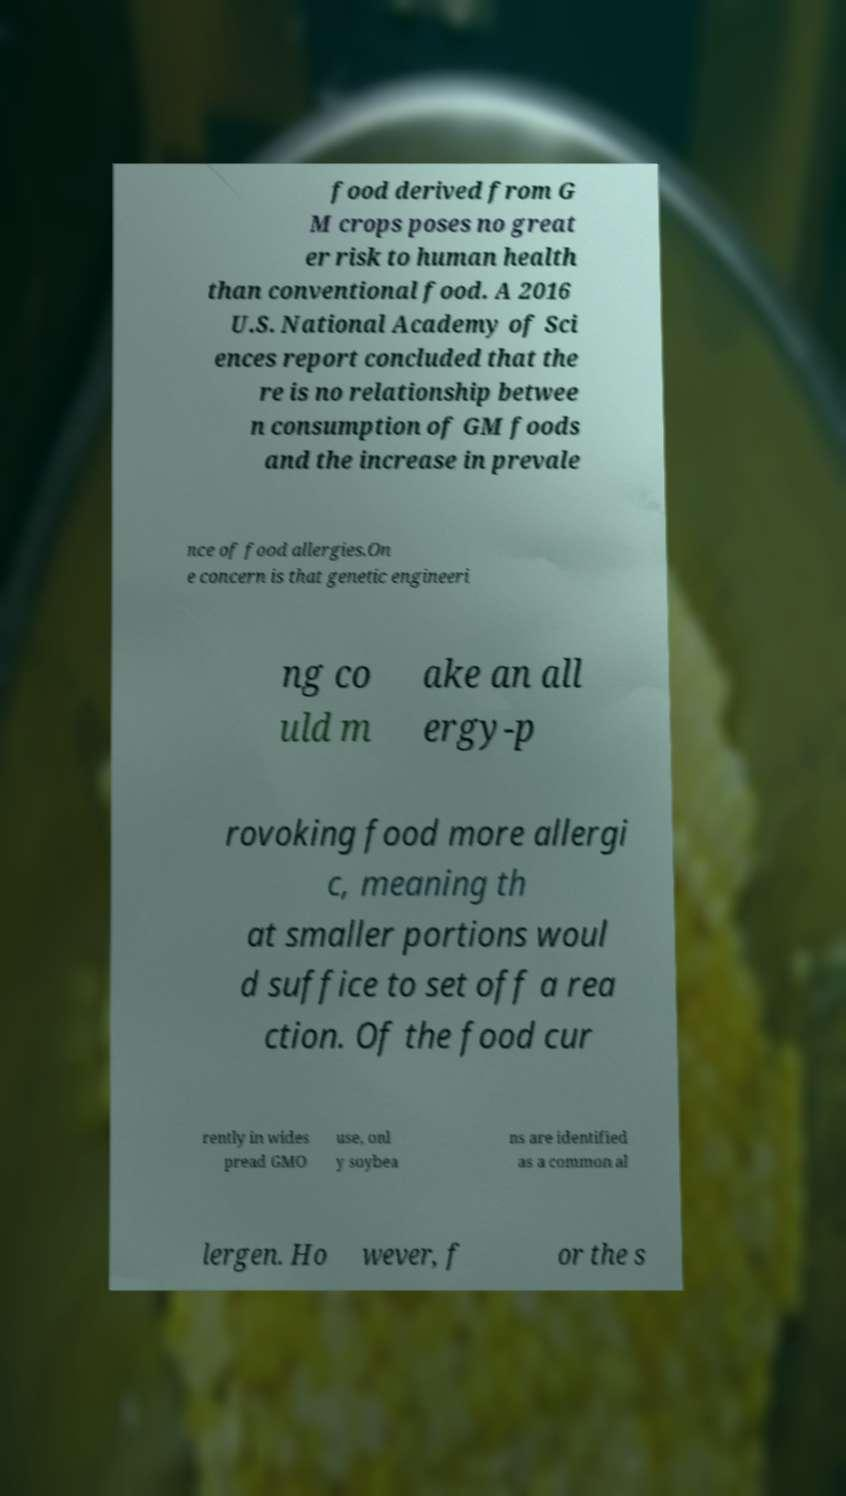Can you read and provide the text displayed in the image?This photo seems to have some interesting text. Can you extract and type it out for me? food derived from G M crops poses no great er risk to human health than conventional food. A 2016 U.S. National Academy of Sci ences report concluded that the re is no relationship betwee n consumption of GM foods and the increase in prevale nce of food allergies.On e concern is that genetic engineeri ng co uld m ake an all ergy-p rovoking food more allergi c, meaning th at smaller portions woul d suffice to set off a rea ction. Of the food cur rently in wides pread GMO use, onl y soybea ns are identified as a common al lergen. Ho wever, f or the s 